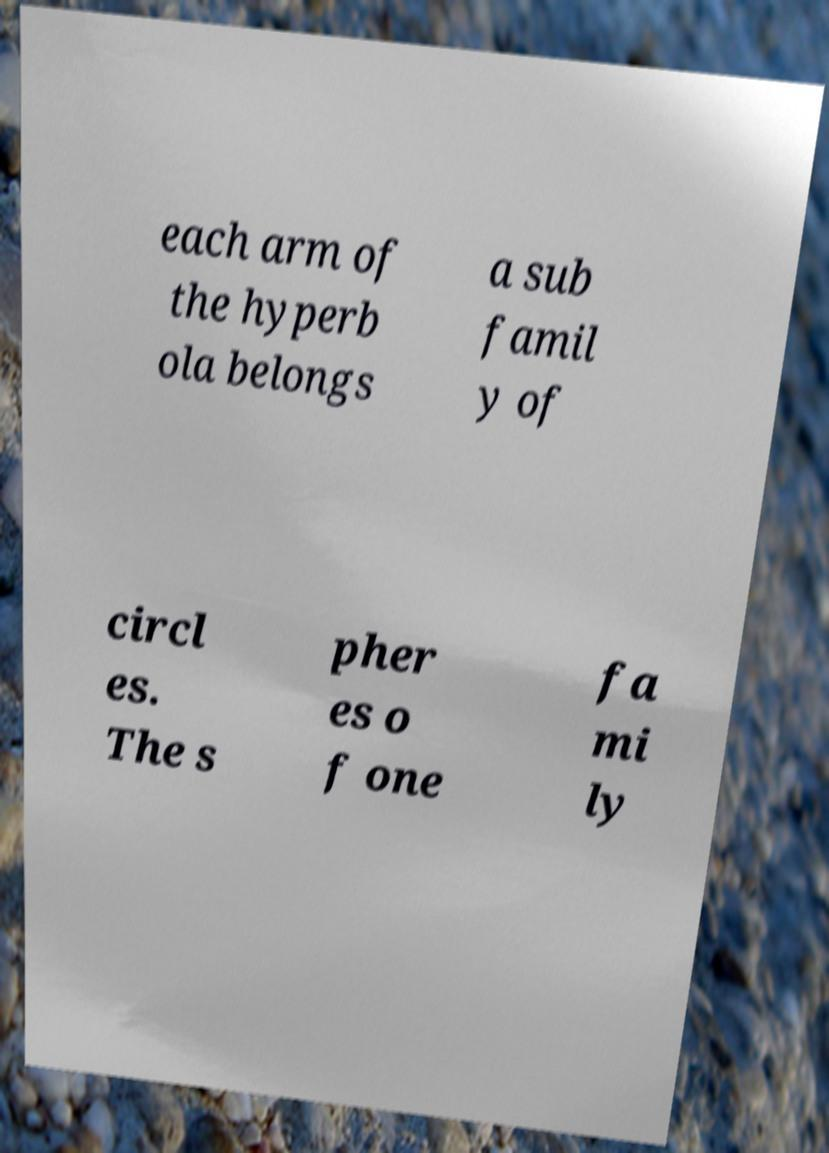What messages or text are displayed in this image? I need them in a readable, typed format. each arm of the hyperb ola belongs a sub famil y of circl es. The s pher es o f one fa mi ly 